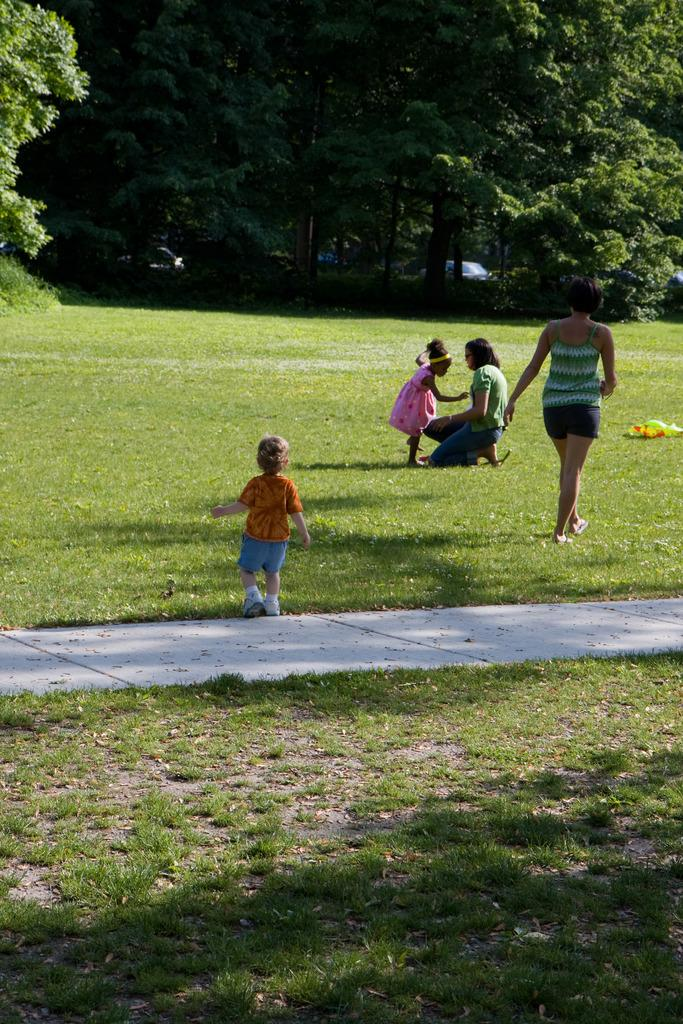What can be seen in the foreground of the image? There are people and grassland in the foreground of the image. What is visible in the background of the image? There are vehicles and trees in the background of the image. What type of seat is visible in the image? There is no seat present in the image. What day of the week is depicted in the image? The day of the week cannot be determined from the image. 